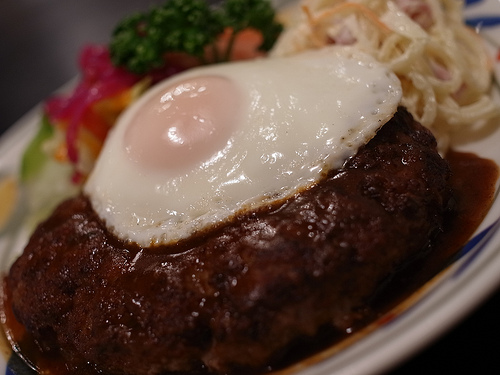<image>
Is the egg next to the steak? No. The egg is not positioned next to the steak. They are located in different areas of the scene. 